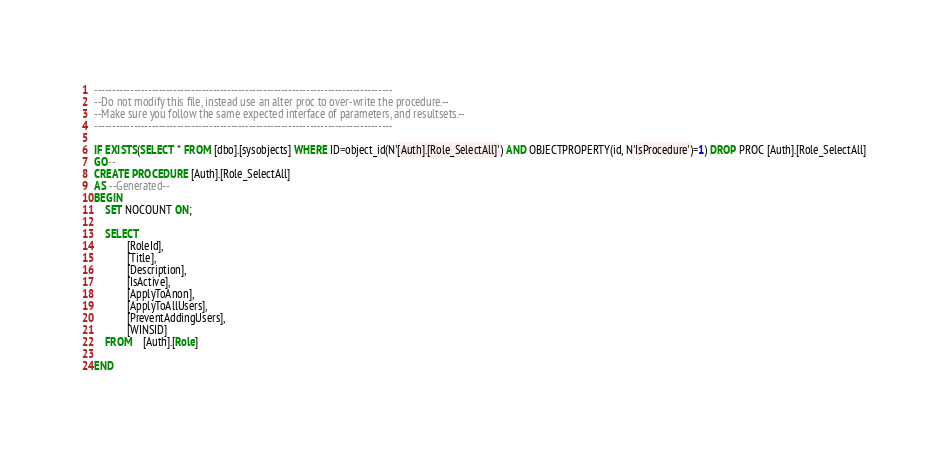Convert code to text. <code><loc_0><loc_0><loc_500><loc_500><_SQL_>-----------------------------------------------------------------------------------
--Do not modify this file, instead use an alter proc to over-write the procedure.--
--Make sure you follow the same expected interface of parameters, and resultsets.--
-----------------------------------------------------------------------------------

IF EXISTS(SELECT * FROM [dbo].[sysobjects] WHERE ID=object_id(N'[Auth].[Role_SelectAll]') AND OBJECTPROPERTY(id, N'IsProcedure')=1) DROP PROC [Auth].[Role_SelectAll]
GO--
CREATE PROCEDURE [Auth].[Role_SelectAll]
AS --Generated--
BEGIN
	SET NOCOUNT ON;

	SELECT	
			[RoleId],
			[Title],
			[Description],
			[IsActive],
			[ApplyToAnon],
			[ApplyToAllUsers],
			[PreventAddingUsers],
			[WINSID]
	FROM	[Auth].[Role]

END</code> 